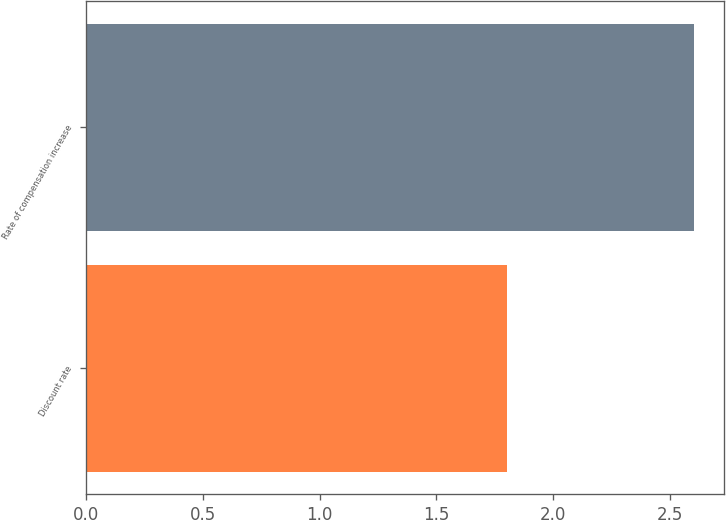Convert chart to OTSL. <chart><loc_0><loc_0><loc_500><loc_500><bar_chart><fcel>Discount rate<fcel>Rate of compensation increase<nl><fcel>1.8<fcel>2.6<nl></chart> 